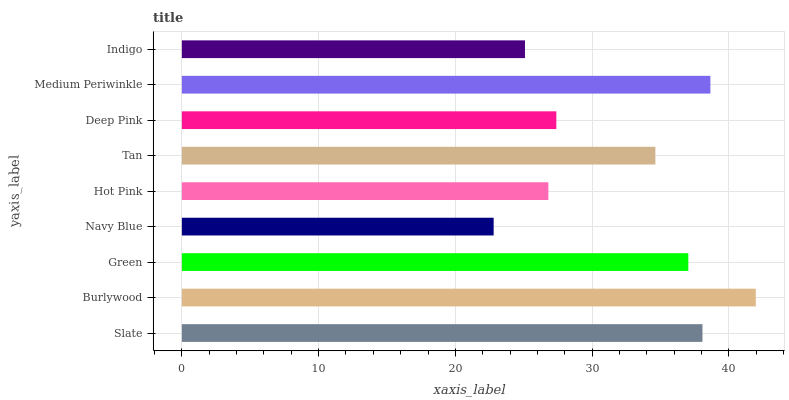Is Navy Blue the minimum?
Answer yes or no. Yes. Is Burlywood the maximum?
Answer yes or no. Yes. Is Green the minimum?
Answer yes or no. No. Is Green the maximum?
Answer yes or no. No. Is Burlywood greater than Green?
Answer yes or no. Yes. Is Green less than Burlywood?
Answer yes or no. Yes. Is Green greater than Burlywood?
Answer yes or no. No. Is Burlywood less than Green?
Answer yes or no. No. Is Tan the high median?
Answer yes or no. Yes. Is Tan the low median?
Answer yes or no. Yes. Is Navy Blue the high median?
Answer yes or no. No. Is Medium Periwinkle the low median?
Answer yes or no. No. 